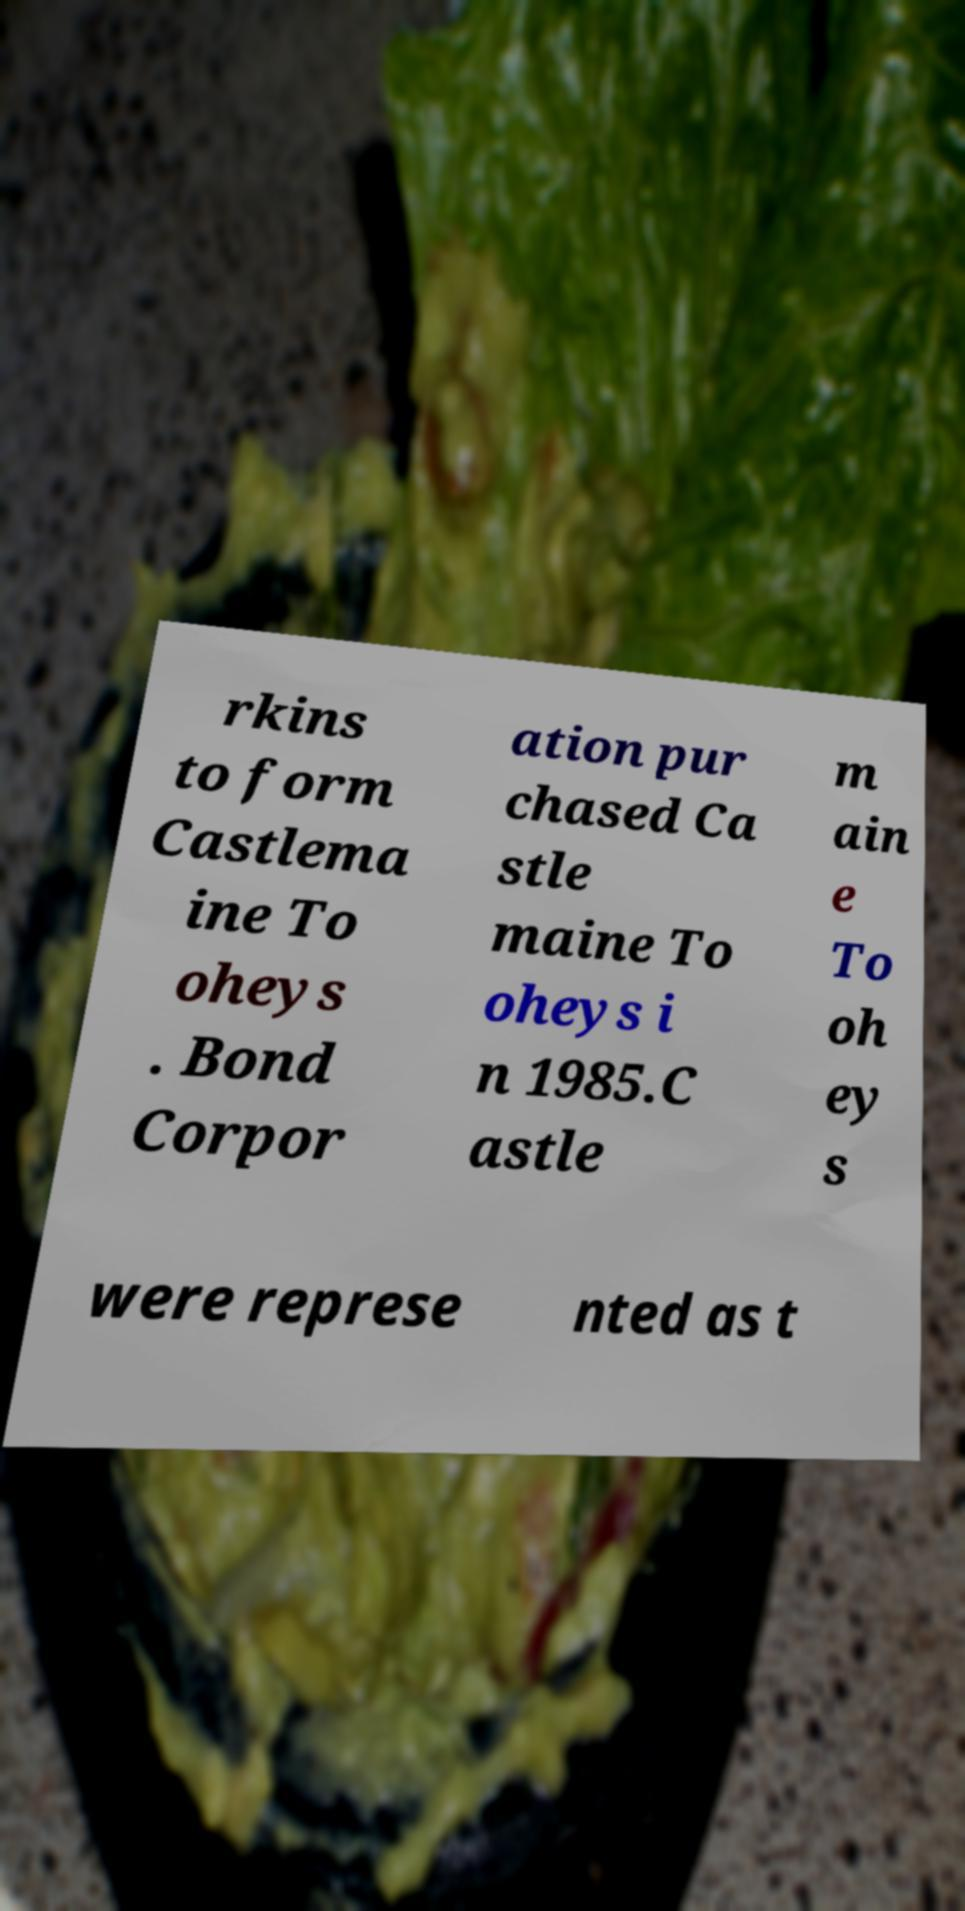For documentation purposes, I need the text within this image transcribed. Could you provide that? rkins to form Castlema ine To oheys . Bond Corpor ation pur chased Ca stle maine To oheys i n 1985.C astle m ain e To oh ey s were represe nted as t 